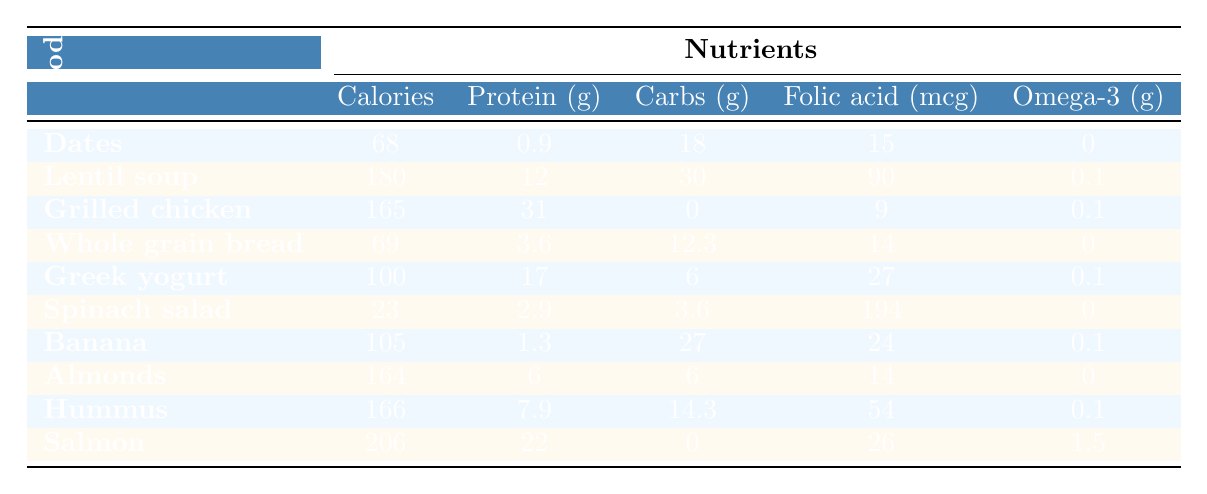What food has the highest protein content? Looking at the protein values in the table, Grilled Chicken Breast has the highest protein content with 31 grams.
Answer: Grilled Chicken Breast Which food provides the most calories? By comparing the calorie values, Salmon provides the most calories with 206.
Answer: Salmon Does Lentil Soup contain more carbohydrates than Whole Grain Bread? Lentil Soup has 30 grams of carbohydrates, while Whole Grain Bread has 12. Therefore, Lentil Soup does contain more carbohydrates.
Answer: Yes What is the total amount of Folic Acid present in Dates and Spinach Salad? Dates contain 15 mcg and Spinach Salad contains 194 mcg. Adding these gives 15 + 194 = 209 mcg.
Answer: 209 mcg Is there any food that offers Omega-3 fatty acids? Checking the Omega-3 values in the table, only Salmon and Lentil Soup provide Omega-3 fatty acids, with Salmon providing the most at 1.5 grams.
Answer: Yes What food has the lowest calcium content? Reviewing the calcium values, Spinach Salad has the lowest calcium content with 99 mg.
Answer: Spinach Salad Calculate the average calorie content of all the foods listed. The total calories for all foods is (68 + 180 + 165 + 69 + 100 + 23 + 105 + 164 + 166 + 206) = 1,221. There are 10 foods, so the average is 1,221 / 10 = 122.1.
Answer: 122.1 Which food has the highest amount of Iron? Looking at the Iron values, Salmon and Lentil Soup both have 3.5 mg of iron, which is the maximum value.
Answer: Salmon and Lentil Soup How many foods contain more than 100 calories? The foods that contain more than 100 calories are Lentil Soup, Grilled Chicken Breast, Greek Yogurt, Banana, Almonds, Hummus, and Salmon, totaling 7 foods.
Answer: 7 foods What nutrient has the highest amount listed for Spinach Salad? For Spinach Salad, the highest nutrient listed is Folic Acid with 194 mcg.
Answer: Folic Acid 